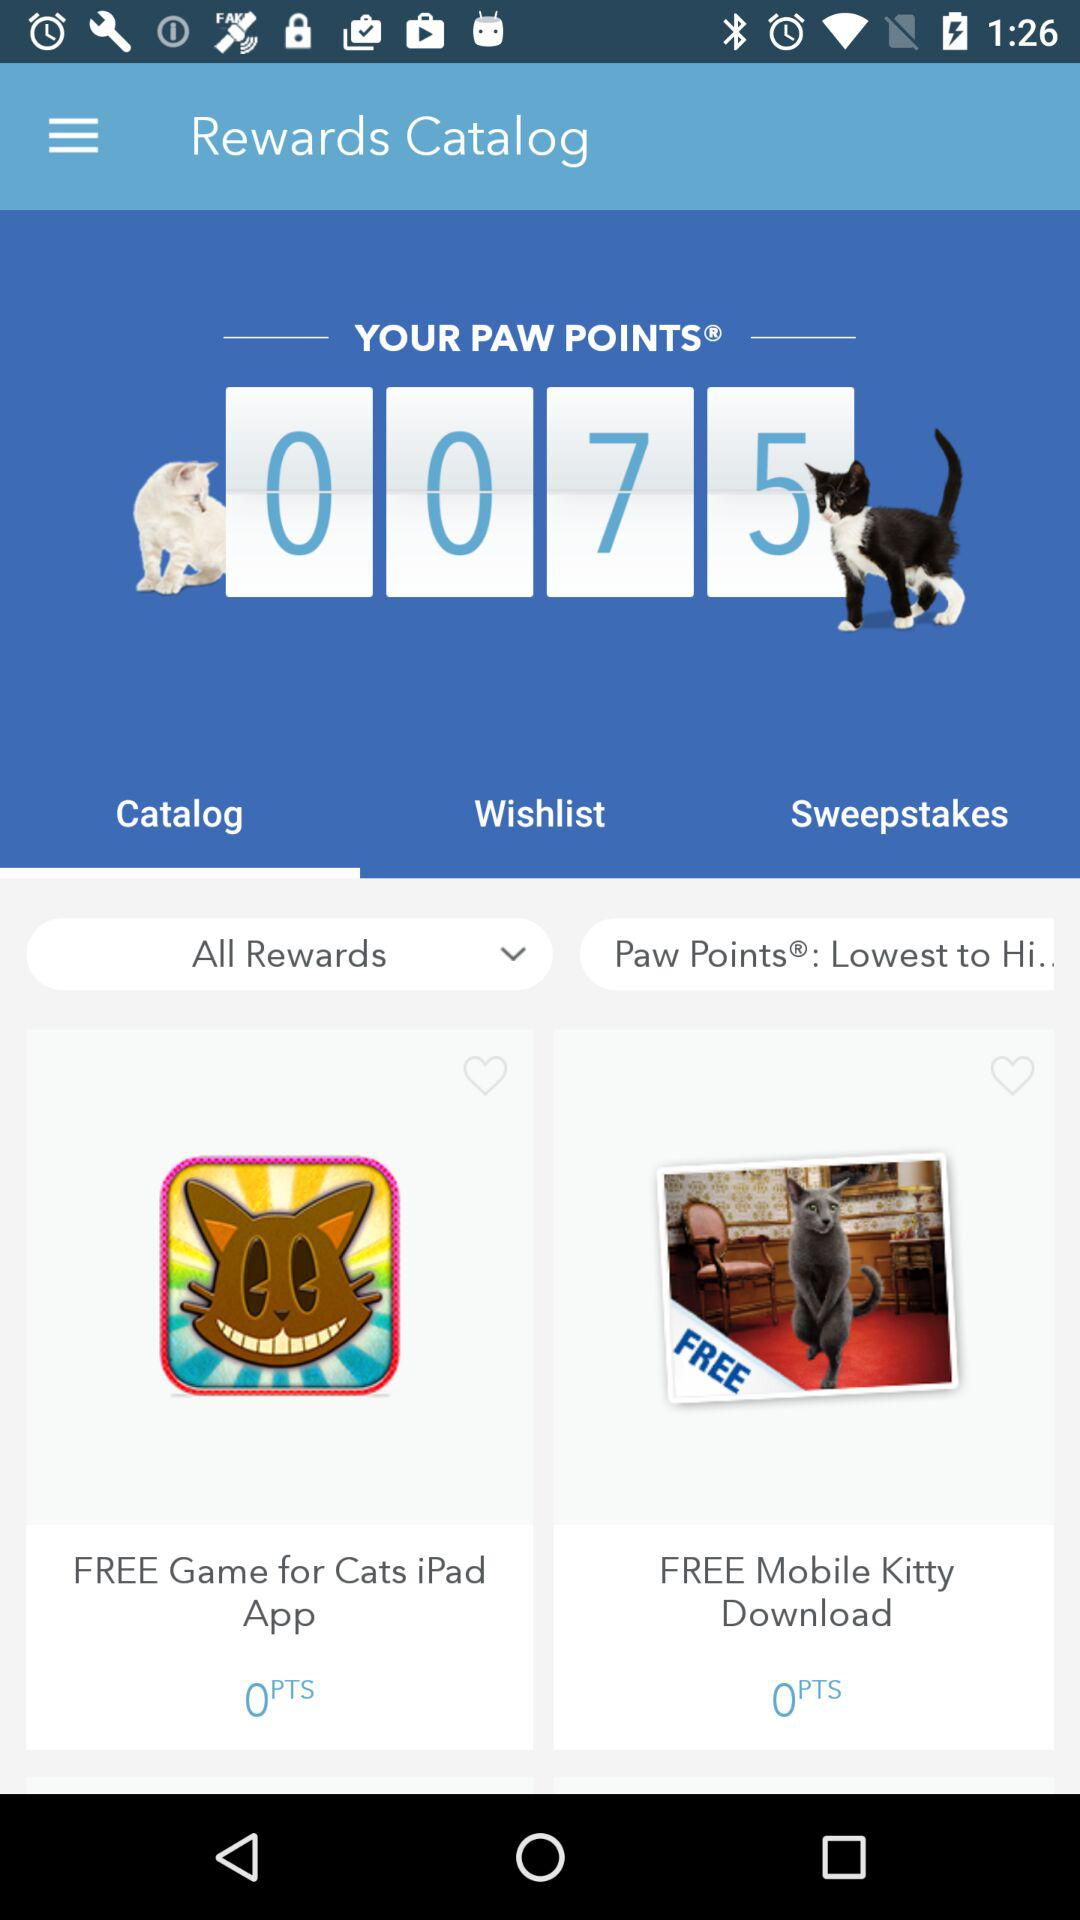How many paw points are needed for the Mobile Kitty application? The paw points needed are 0. 